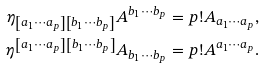<formula> <loc_0><loc_0><loc_500><loc_500>\eta _ { \left [ a _ { 1 } \cdots a _ { p } \right ] \left [ b _ { 1 } \cdots b _ { p } \right ] } A ^ { b _ { 1 } \cdots b _ { p } } & = p ! A _ { a _ { 1 } \cdots a _ { p } } , \\ \eta ^ { \left [ a _ { 1 } \cdots a _ { p } \right ] \left [ b _ { 1 } \cdots b _ { p } \right ] } A _ { b _ { 1 } \cdots b _ { p } } & = p ! A ^ { a _ { 1 } \cdots a _ { p } } .</formula> 